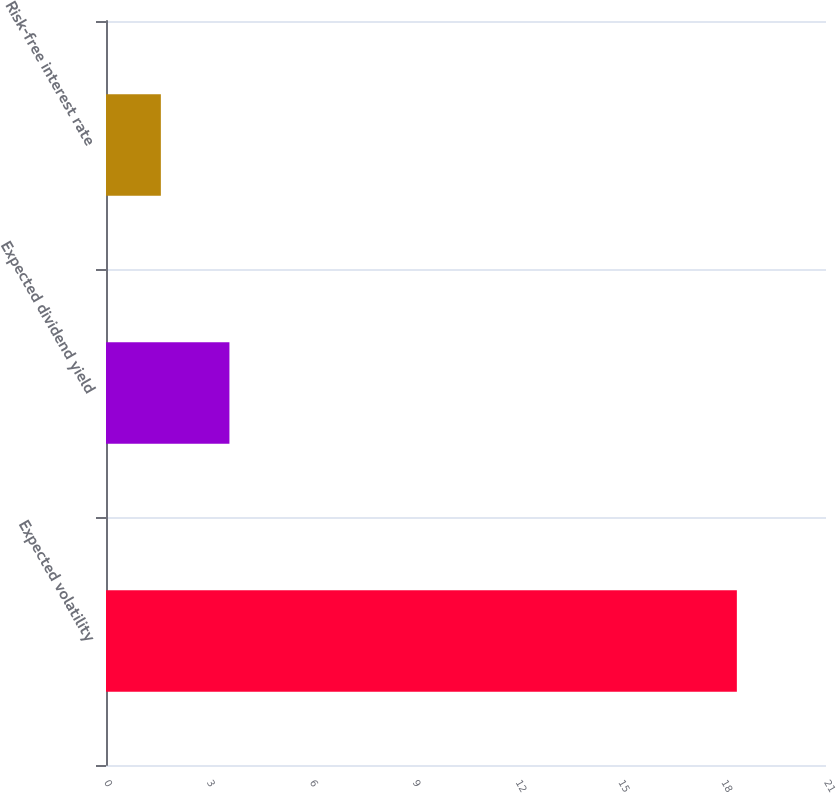<chart> <loc_0><loc_0><loc_500><loc_500><bar_chart><fcel>Expected volatility<fcel>Expected dividend yield<fcel>Risk-free interest rate<nl><fcel>18.4<fcel>3.6<fcel>1.6<nl></chart> 